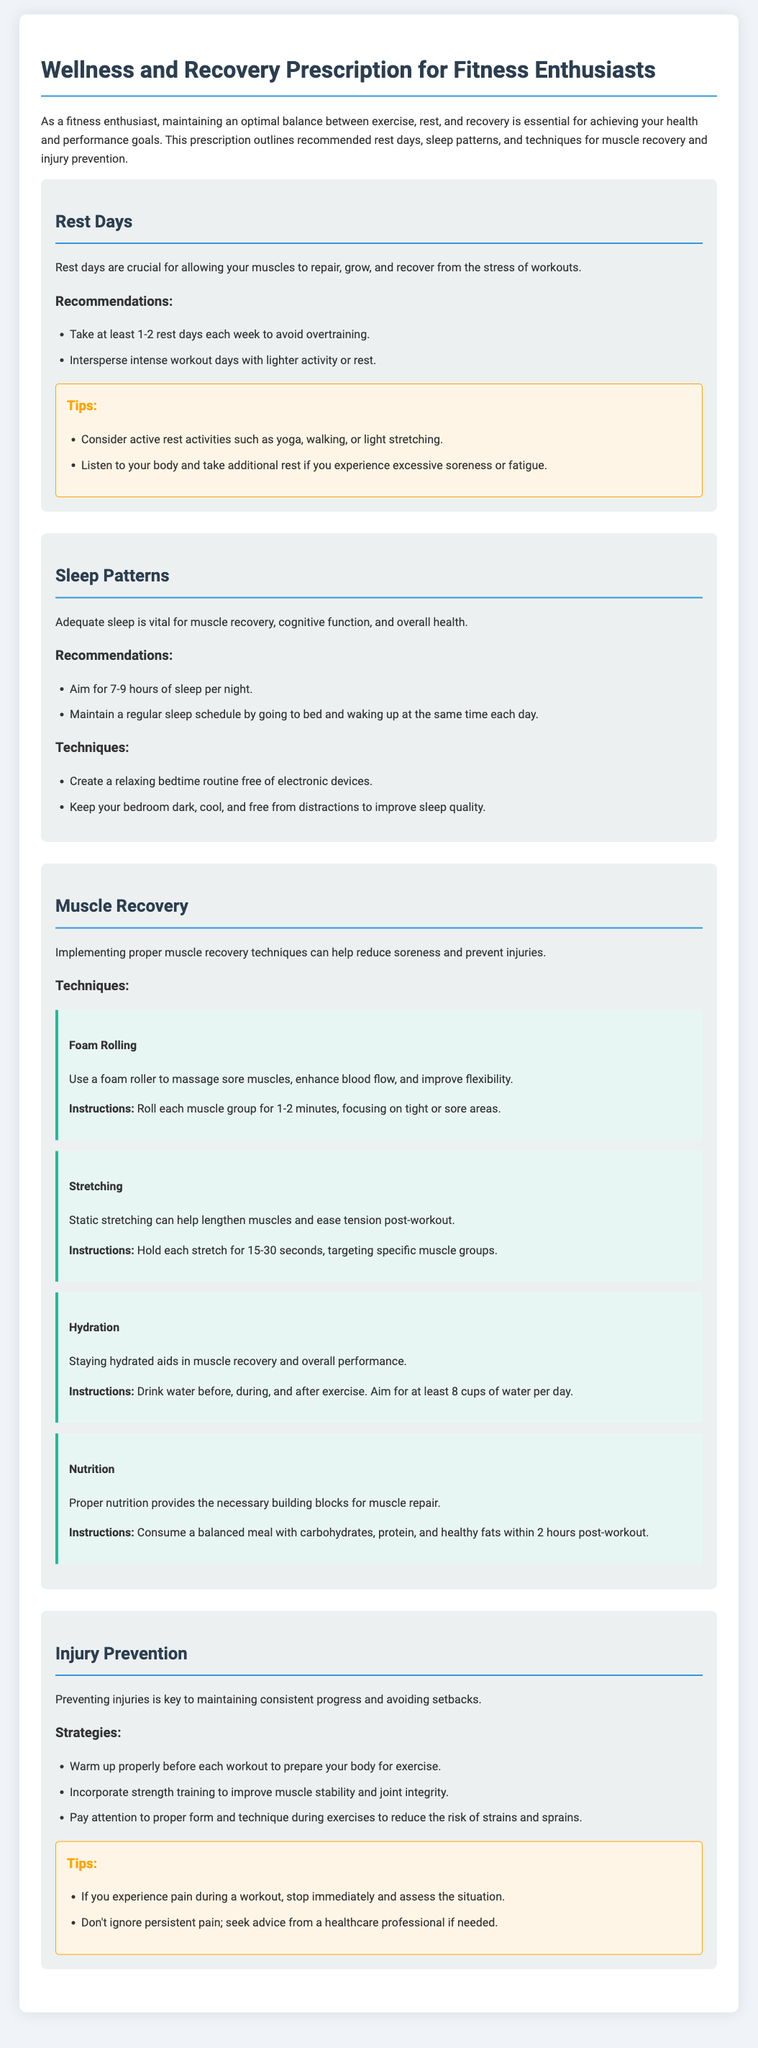What are the recommended rest days? The document states to take at least 1-2 rest days each week to avoid overtraining.
Answer: 1-2 rest days What is the ideal amount of sleep recommended? The document recommends aiming for 7-9 hours of sleep per night.
Answer: 7-9 hours What technique is suggested for enhancing blood flow and flexibility? The document mentions using foam rolling to massage sore muscles for these benefits.
Answer: Foam Rolling What is one way to improve sleep quality according to the document? The document suggests keeping your bedroom dark, cool, and free from distractions.
Answer: Dark, cool, and distraction-free How often should hydration be maintained during exercise? The document advises drinking water before, during, and after exercise.
Answer: Before, during, and after What should be consumed within 2 hours post-workout? The document recommends a balanced meal with carbohydrates, protein, and healthy fats after a workout.
Answer: Balanced meal What is a recommended strategy to prevent injuries? The document includes proper warming up before each workout as a key injury prevention strategy.
Answer: Warm up properly What is advised if one experiences pain during a workout? The document states to stop immediately and assess the situation if pain occurs during exercise.
Answer: Stop immediately How long should each stretch be held according to the document? The document states to hold each stretch for 15-30 seconds targeting specific muscle groups.
Answer: 15-30 seconds 